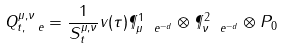Convert formula to latex. <formula><loc_0><loc_0><loc_500><loc_500>Q _ { t , \ e } ^ { \mu , \nu } = \frac { 1 } { S _ { t } ^ { \mu , \nu } } v ( \tau ) \P ^ { 1 } _ { \mu \ e ^ { - d } } \otimes \P ^ { 2 } _ { \nu \ e ^ { - d } } \otimes P _ { 0 }</formula> 